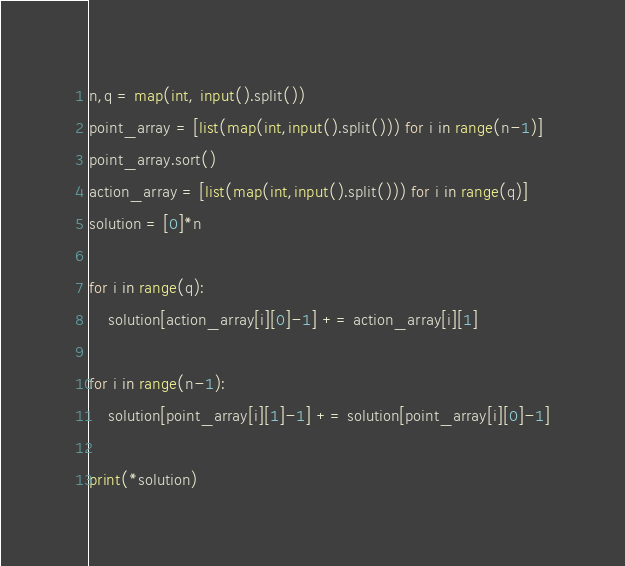<code> <loc_0><loc_0><loc_500><loc_500><_Python_>n,q = map(int, input().split())
point_array = [list(map(int,input().split())) for i in range(n-1)]
point_array.sort()
action_array = [list(map(int,input().split())) for i in range(q)]
solution = [0]*n

for i in range(q):
    solution[action_array[i][0]-1] += action_array[i][1]

for i in range(n-1):
    solution[point_array[i][1]-1] += solution[point_array[i][0]-1]
    
print(*solution)</code> 